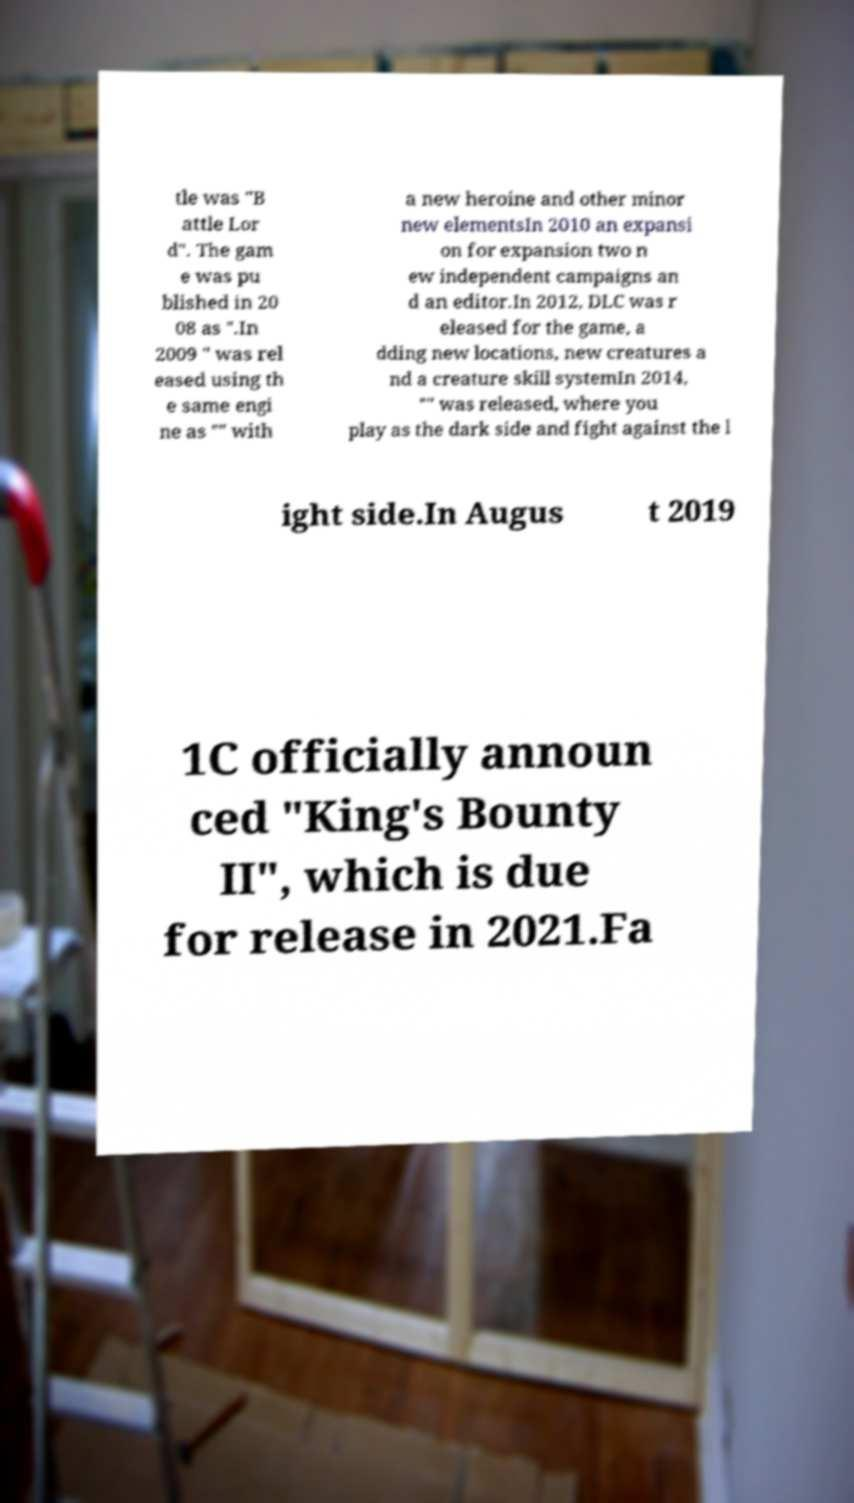There's text embedded in this image that I need extracted. Can you transcribe it verbatim? tle was "B attle Lor d". The gam e was pu blished in 20 08 as ".In 2009 " was rel eased using th e same engi ne as "" with a new heroine and other minor new elementsIn 2010 an expansi on for expansion two n ew independent campaigns an d an editor.In 2012, DLC was r eleased for the game, a dding new locations, new creatures a nd a creature skill systemIn 2014, "" was released, where you play as the dark side and fight against the l ight side.In Augus t 2019 1C officially announ ced "King's Bounty II", which is due for release in 2021.Fa 